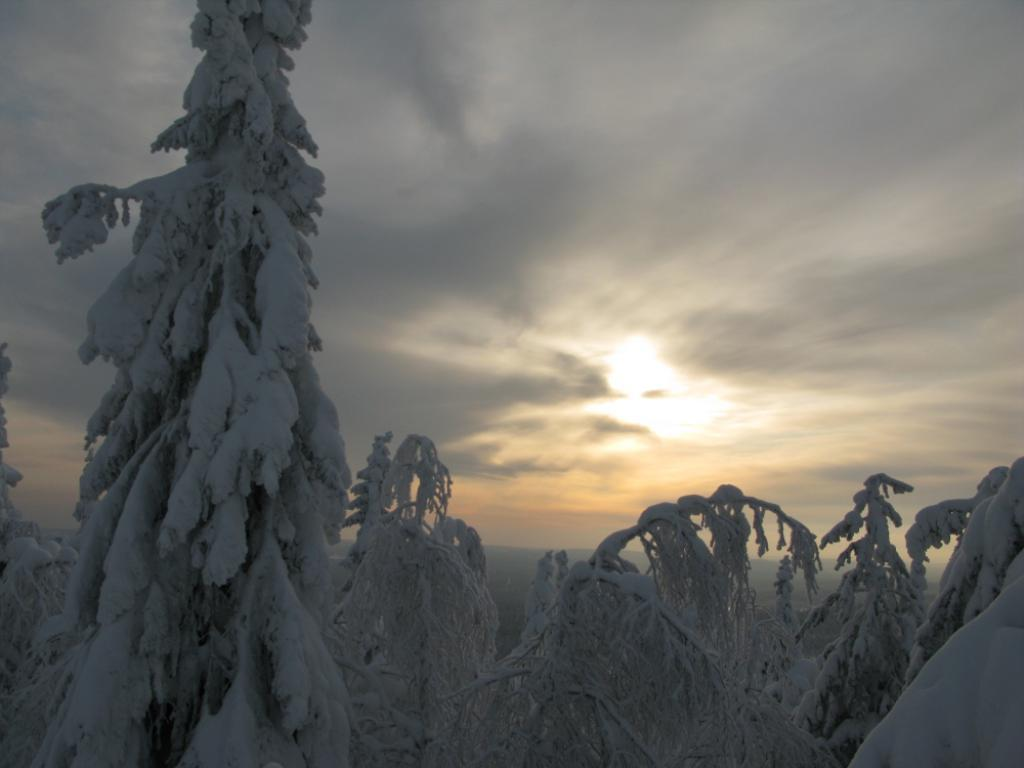What type of vegetation is present in the image? There are trees in the image. What is covering the trees in the image? The trees have snow on them. What part of the natural environment is visible in the image? The sky is visible in the image. What type of sound can be heard coming from the trees in the image? There is no sound coming from the trees in the image, as it is a still image. 